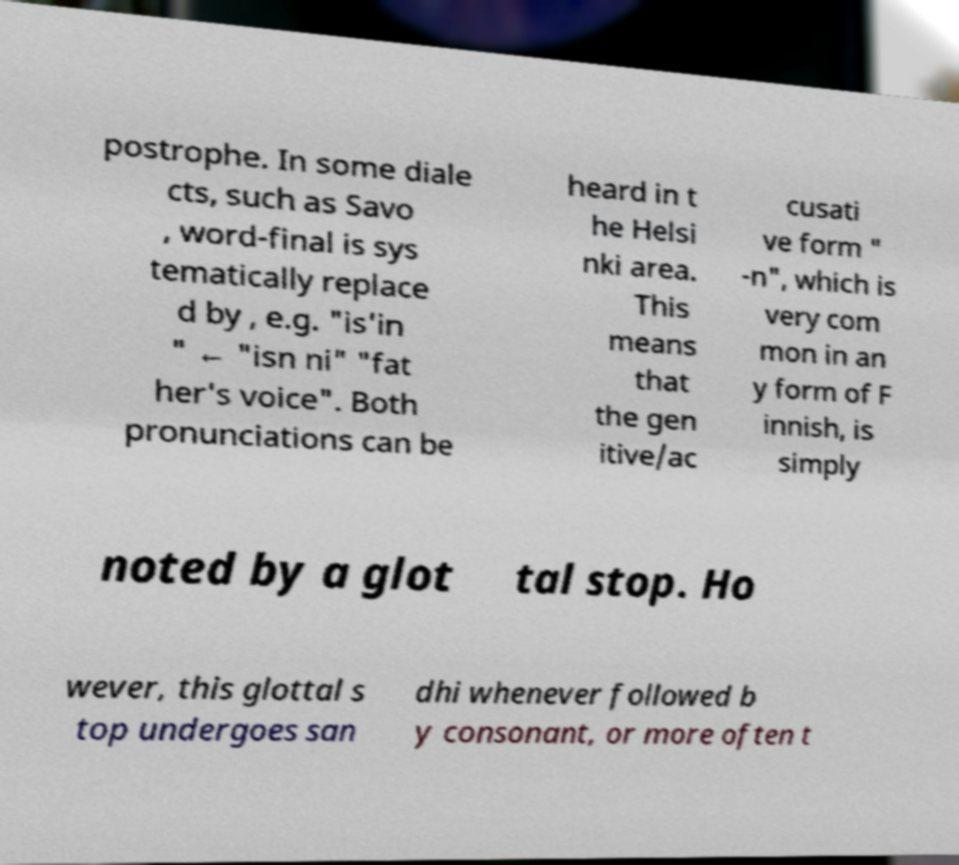What messages or text are displayed in this image? I need them in a readable, typed format. postrophe. In some diale cts, such as Savo , word-final is sys tematically replace d by , e.g. "is'in " ← "isn ni" "fat her's voice". Both pronunciations can be heard in t he Helsi nki area. This means that the gen itive/ac cusati ve form " -n", which is very com mon in an y form of F innish, is simply noted by a glot tal stop. Ho wever, this glottal s top undergoes san dhi whenever followed b y consonant, or more often t 